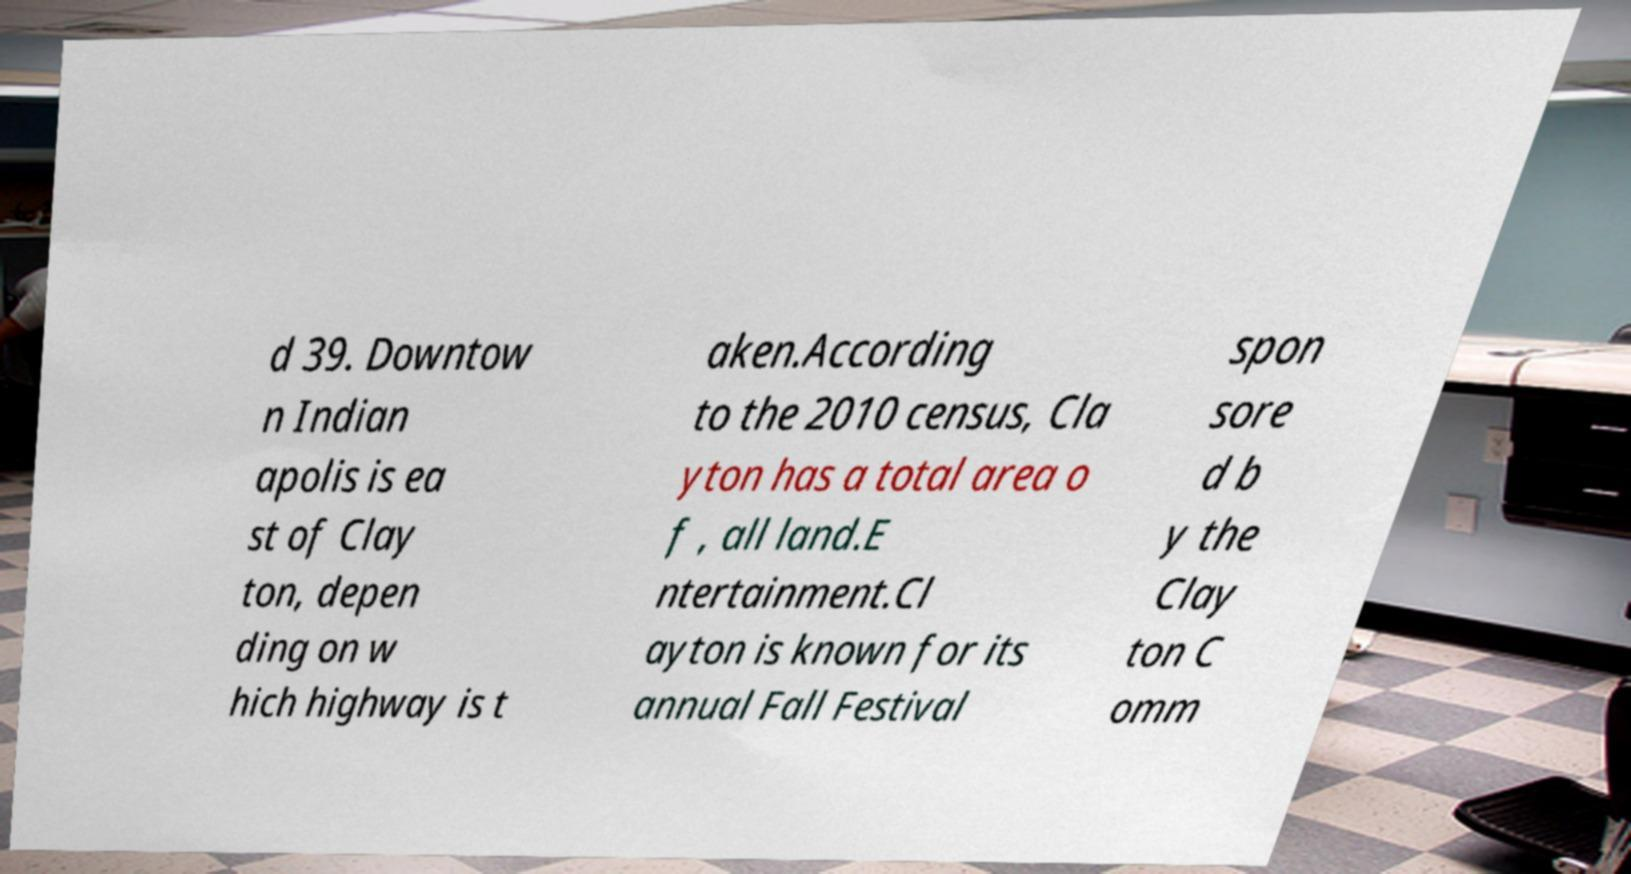For documentation purposes, I need the text within this image transcribed. Could you provide that? d 39. Downtow n Indian apolis is ea st of Clay ton, depen ding on w hich highway is t aken.According to the 2010 census, Cla yton has a total area o f , all land.E ntertainment.Cl ayton is known for its annual Fall Festival spon sore d b y the Clay ton C omm 